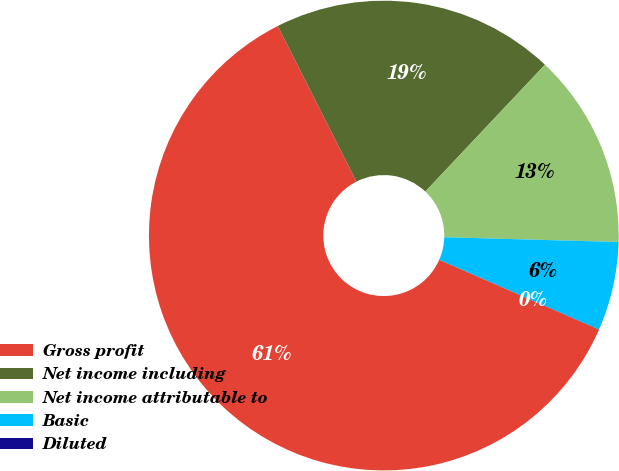<chart> <loc_0><loc_0><loc_500><loc_500><pie_chart><fcel>Gross profit<fcel>Net income including<fcel>Net income attributable to<fcel>Basic<fcel>Diluted<nl><fcel>60.98%<fcel>19.49%<fcel>13.4%<fcel>6.11%<fcel>0.01%<nl></chart> 